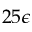Convert formula to latex. <formula><loc_0><loc_0><loc_500><loc_500>2 5 \epsilon</formula> 